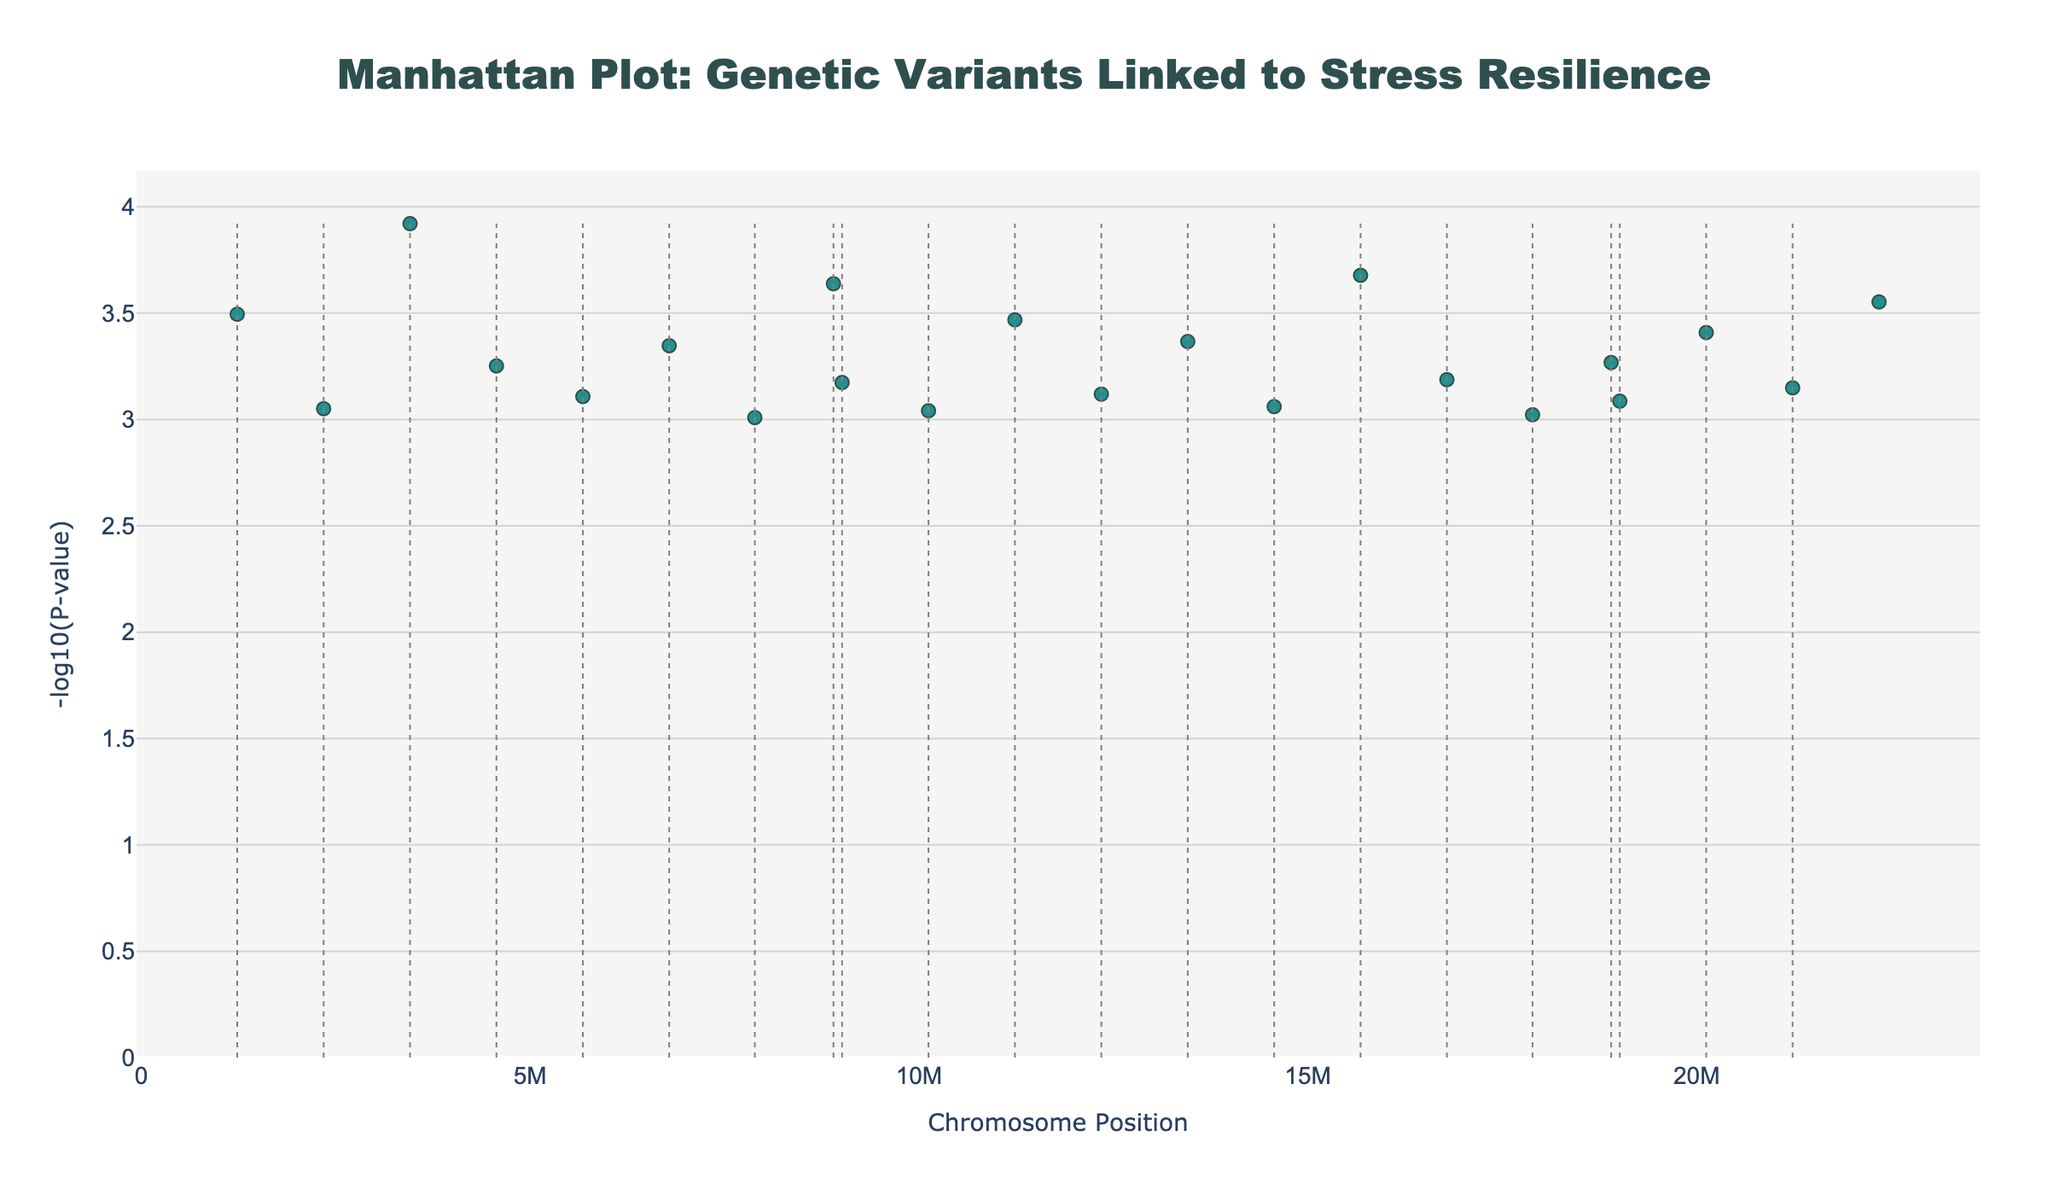What's the title of the plot? The title is prominently displayed at the top center of the plot. It reads 'Manhattan Plot: Genetic Variants Linked to Stress Resilience'.
Answer: Manhattan Plot: Genetic Variants Linked to Stress Resilience What does the y-axis represent? The y-axis typically shows the -log10(P-value) in a Manhattan plot. This measurement indicates the statistical significance of each genetic variant, with higher values representing more significant variants.
Answer: -log10(P-value) Which SNP has the lowest P-value? To find the SNP with the lowest P-value, look for the highest point on the y-axis because this plot uses -log10(P-value). Based on the data, the SNP rs53576 on chromosome 3 has the highest -log10(P-value).
Answer: rs53576 How many SNPs are plotted in the figure? Each marker represents an SNP, hence count the number of unique markers. According to the data, there are 22 SNPs displayed in the figure.
Answer: 22 Which chromosome has the most significant genetic variant in terms of P-value? Identify the highest point across all chromosomes, as the highest -log10(P-value) signifies the most significant P-value. This highest point is on chromosome 3.
Answer: Chromosome 3 Compare the SNPs rs4680 and rs6313, which one has a lower P-value? A lower P-value corresponds to a higher -log10(P-value). Locate the points for SNPs rs4680 and rs6313; rs4680's point is higher on the y-axis than rs6313, thus indicating a lower P-value.
Answer: rs4680 Which Chromosomes have SNPs with P-values less than 0.0005? P-values below 0.0005 correspond to -log10(P-value) greater than -log10(0.0005) = 3.301. Look for points above y=3.301 and note their chromosomes: 1, 3, 4, 8, 15, and 22.
Answer: Chromosomes 1, 3, 4, 8, 15, 22 What distinguishes the scatter plots of different chromosomes? Different chromosomes are distinguished by varying colors and each has markers placed at different x-positions denoting their specific chromosome and position. The colors follow a 'Viridis' colorscale.
Answer: Color and position Are there any chromosomes without significant SNPs? In a Manhattan plot, lack of points indicates no significant SNPs. Here, all the chromosomes from 1 to 22 have plotted SNPs, meaning they all have significant SNPs.
Answer: No What is the approximate -log10(P-value) range displayed in the plot? The plot shows SNPs whose -log10(P-value) values range from just above 3 to just below 4 since P-values from 0.00098 to 0.00012 correspond roughly to -log10(P-value) from approximately 3.01 to 3.92.
Answer: Approximately 3 to 4 